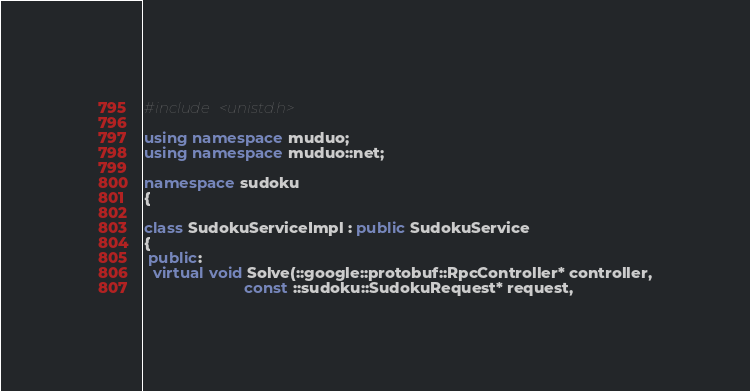Convert code to text. <code><loc_0><loc_0><loc_500><loc_500><_C++_>#include <unistd.h>

using namespace muduo;
using namespace muduo::net;

namespace sudoku
{

class SudokuServiceImpl : public SudokuService
{
 public:
  virtual void Solve(::google::protobuf::RpcController* controller,
                       const ::sudoku::SudokuRequest* request,</code> 